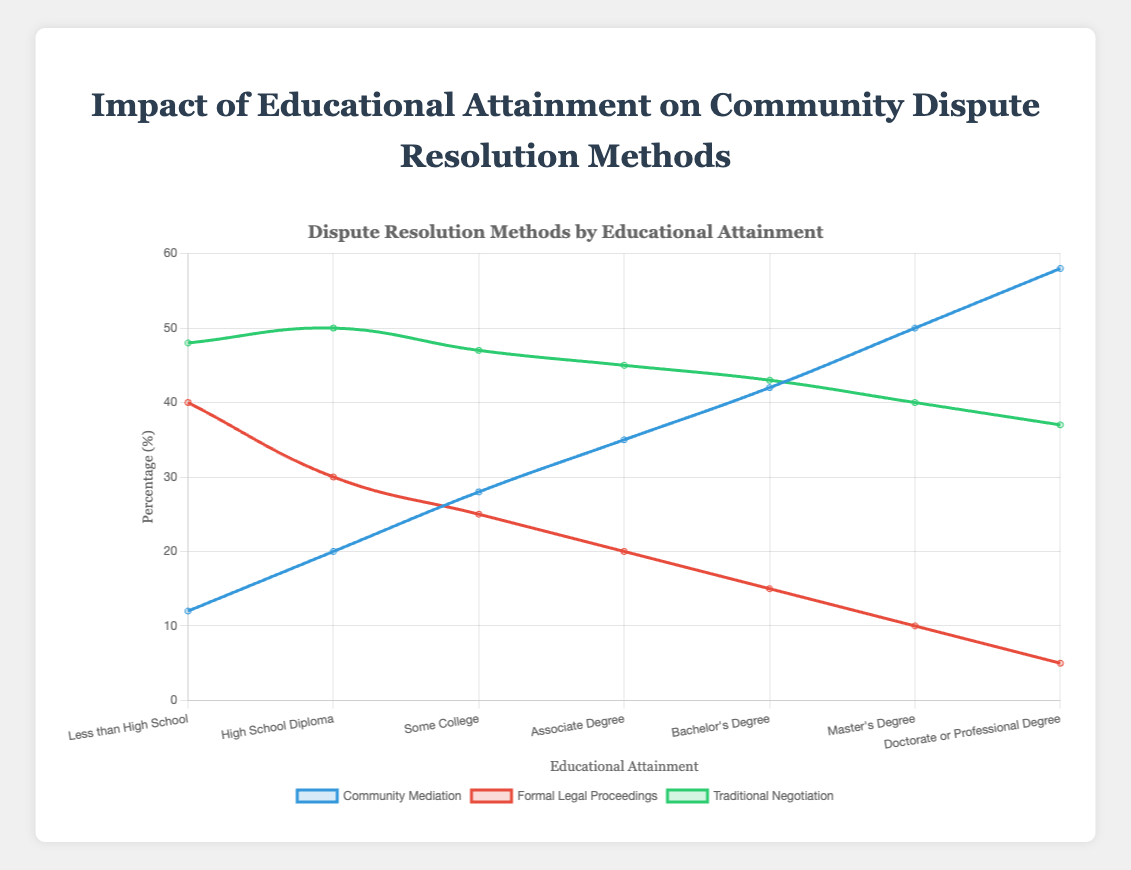What is the percentage of people with a Doctorate or Professional Degree who use Community Mediation? To find the percentage, look at the data for "Doctorate or Professional Degree" on the "Community Mediation" curve. The value is 58%.
Answer: 58% Which educational group has the highest percentage of Traditional Negotiation usage? Check each educational level to identify the highest value in the "Traditional Negotiation" curve. "High School Diploma" has the highest value at 50%.
Answer: High School Diploma What is the difference in percentage between Formal Legal Proceedings and Community Mediation for people with a Master's Degree? For the Master's Degree group, subtract the percentage of "Formal Legal Proceedings" from "Community Mediation": 50% - 10% = 40%.
Answer: 40% What is the trend for Community Mediation as educational attainment increases? As educational attainment increases, observe the "Community Mediation" curve. The trend shows a consistent increase in percentage.
Answer: Increases How does the preference for Formal Legal Proceedings change as educational attainment rises? Look at the "Formal Legal Proceedings" curve across different educational levels. It shows a decreasing trend as educational attainment increases.
Answer: Decreases Which method of dispute resolution is more common among those with an Associate Degree: Community Mediation or Traditional Negotiation? Check the percentages for "Community Mediation" and "Traditional Negotiation" for "Associate Degree". "Traditional Negotiation" is 45%, and "Community Mediation" is 35%.
Answer: Traditional Negotiation Calculate the average percentage of Community Mediation for all educational levels. Sum all percentages (12 + 20 + 28 + 35 + 42 + 50 + 58 = 245) and divide by the number of levels (7): 245 / 7 ≈ 35%.
Answer: 35% Compare the usage of Traditional Negotiation between people with "Less than High School" and "Bachelor's Degree". Compare the percentages: "Less than High School" is 48%, and "Bachelor's Degree" is 43%. 48% > 43%.
Answer: Less than High School What is the sum of percentages for all three methods of dispute resolution in the "Some College" category? Add percentages for "Some College" across all methods: 28 + 25 + 47 = 100%.
Answer: 100% Which dispute resolution method’s curve is represented by the green color? Identify the curve colored green. The "Traditional Negotiation" method is represented in green.
Answer: Traditional Negotiation 